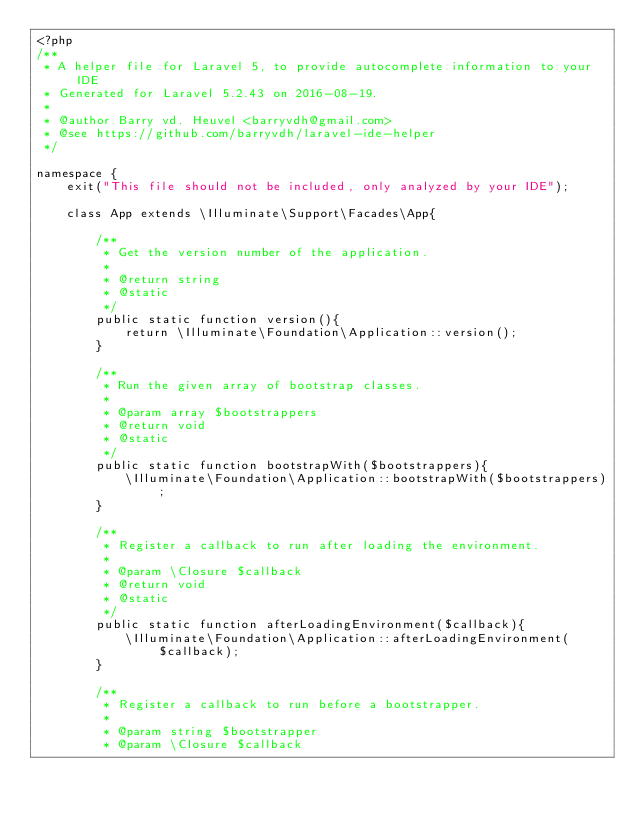<code> <loc_0><loc_0><loc_500><loc_500><_PHP_><?php
/**
 * A helper file for Laravel 5, to provide autocomplete information to your IDE
 * Generated for Laravel 5.2.43 on 2016-08-19.
 *
 * @author Barry vd. Heuvel <barryvdh@gmail.com>
 * @see https://github.com/barryvdh/laravel-ide-helper
 */

namespace {
    exit("This file should not be included, only analyzed by your IDE");

    class App extends \Illuminate\Support\Facades\App{
        
        /**
         * Get the version number of the application.
         *
         * @return string 
         * @static 
         */
        public static function version(){
            return \Illuminate\Foundation\Application::version();
        }
        
        /**
         * Run the given array of bootstrap classes.
         *
         * @param array $bootstrappers
         * @return void 
         * @static 
         */
        public static function bootstrapWith($bootstrappers){
            \Illuminate\Foundation\Application::bootstrapWith($bootstrappers);
        }
        
        /**
         * Register a callback to run after loading the environment.
         *
         * @param \Closure $callback
         * @return void 
         * @static 
         */
        public static function afterLoadingEnvironment($callback){
            \Illuminate\Foundation\Application::afterLoadingEnvironment($callback);
        }
        
        /**
         * Register a callback to run before a bootstrapper.
         *
         * @param string $bootstrapper
         * @param \Closure $callback</code> 